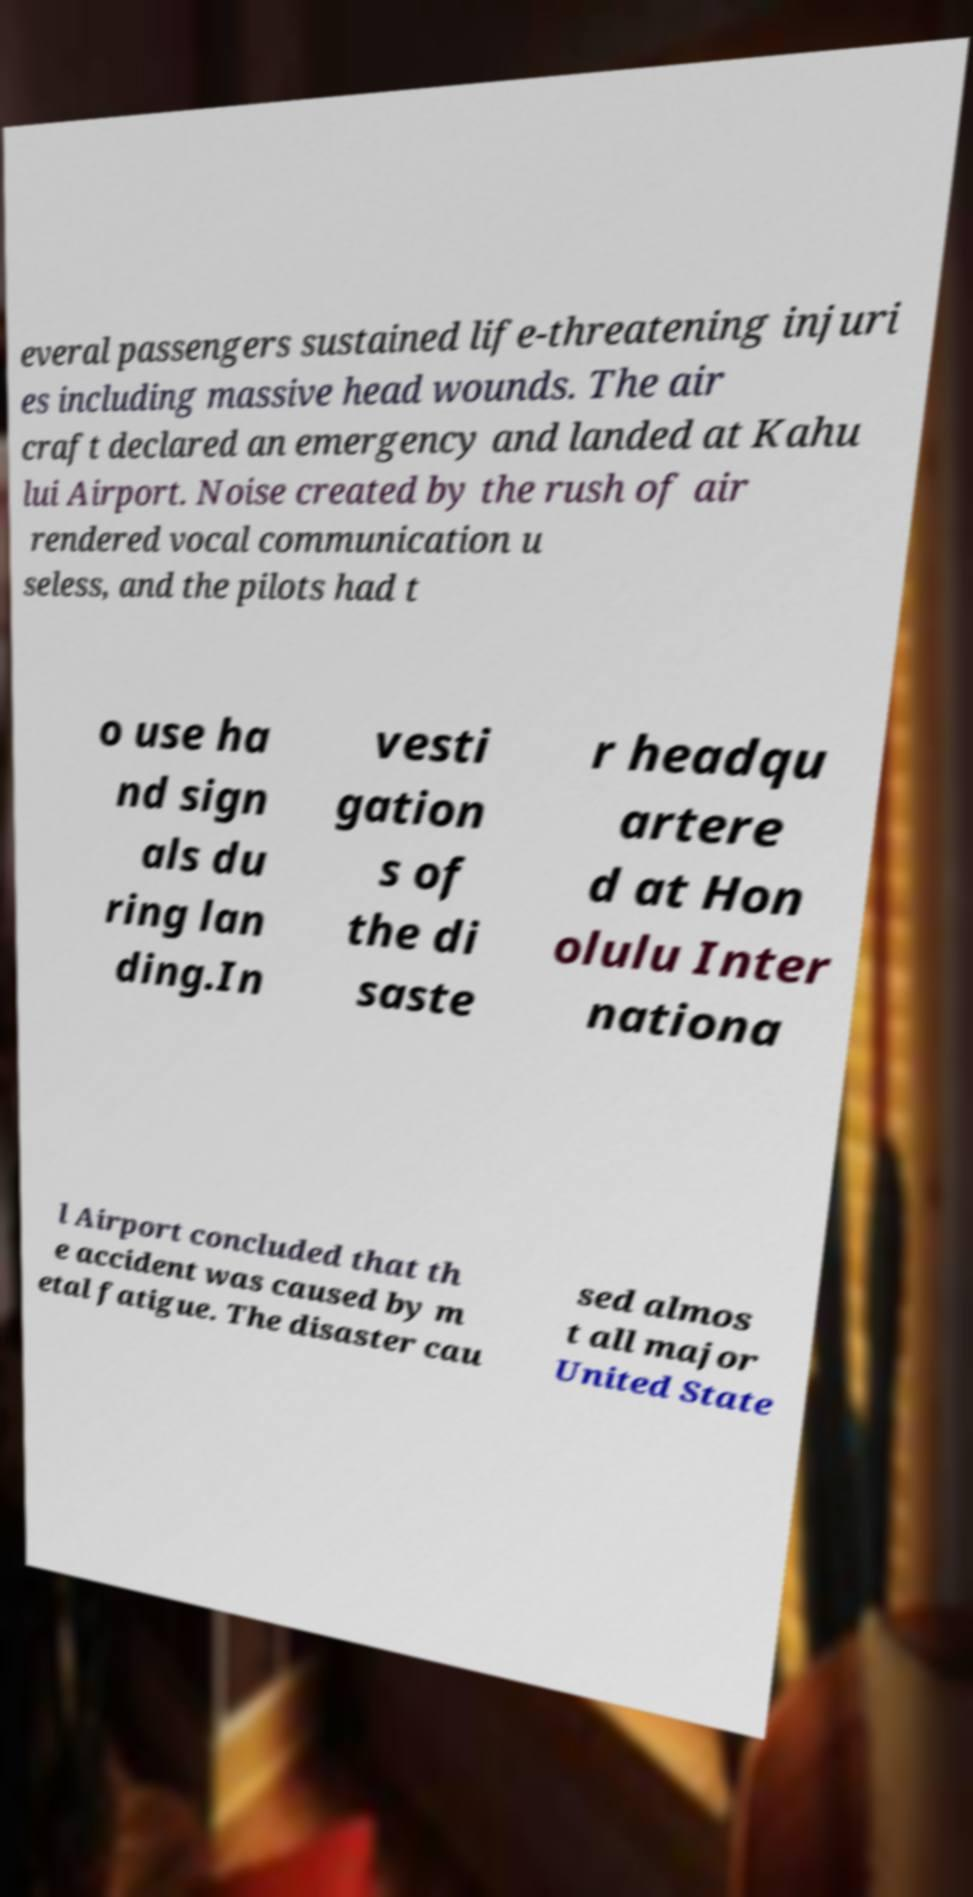What messages or text are displayed in this image? I need them in a readable, typed format. everal passengers sustained life-threatening injuri es including massive head wounds. The air craft declared an emergency and landed at Kahu lui Airport. Noise created by the rush of air rendered vocal communication u seless, and the pilots had t o use ha nd sign als du ring lan ding.In vesti gation s of the di saste r headqu artere d at Hon olulu Inter nationa l Airport concluded that th e accident was caused by m etal fatigue. The disaster cau sed almos t all major United State 